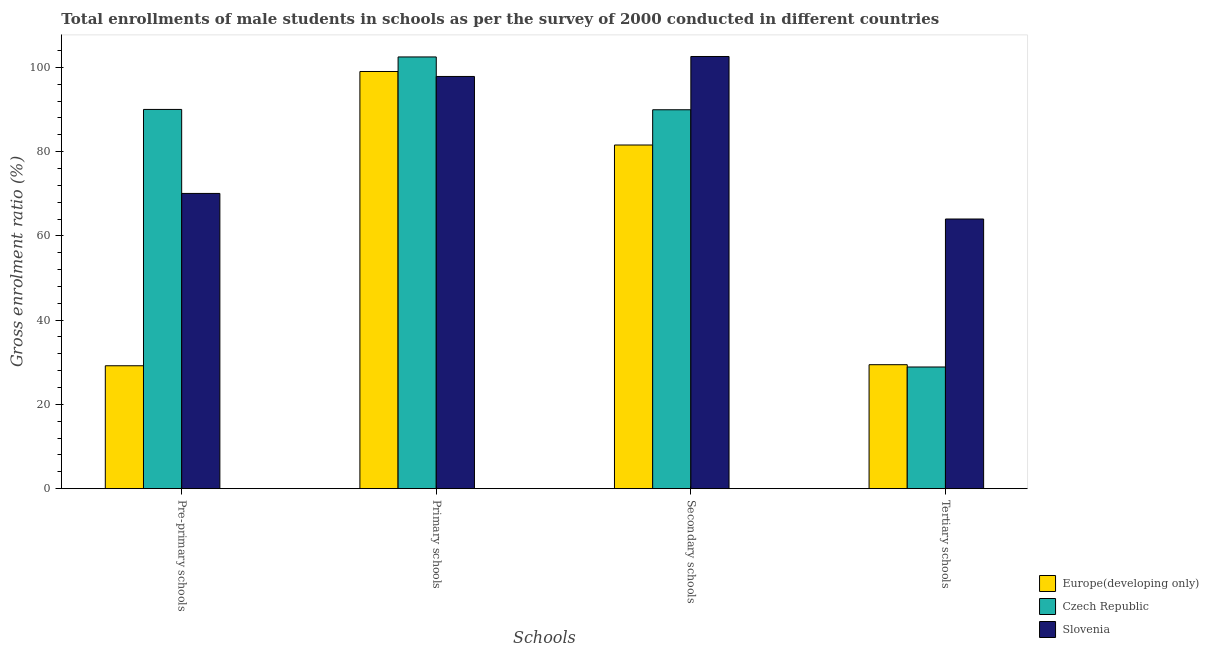How many different coloured bars are there?
Your answer should be compact. 3. How many groups of bars are there?
Your response must be concise. 4. Are the number of bars per tick equal to the number of legend labels?
Provide a short and direct response. Yes. Are the number of bars on each tick of the X-axis equal?
Give a very brief answer. Yes. What is the label of the 4th group of bars from the left?
Your answer should be compact. Tertiary schools. What is the gross enrolment ratio(male) in tertiary schools in Europe(developing only)?
Provide a short and direct response. 29.42. Across all countries, what is the maximum gross enrolment ratio(male) in pre-primary schools?
Keep it short and to the point. 90.01. Across all countries, what is the minimum gross enrolment ratio(male) in pre-primary schools?
Your answer should be compact. 29.17. In which country was the gross enrolment ratio(male) in primary schools maximum?
Your answer should be very brief. Czech Republic. In which country was the gross enrolment ratio(male) in pre-primary schools minimum?
Keep it short and to the point. Europe(developing only). What is the total gross enrolment ratio(male) in pre-primary schools in the graph?
Make the answer very short. 189.25. What is the difference between the gross enrolment ratio(male) in secondary schools in Europe(developing only) and that in Czech Republic?
Provide a succinct answer. -8.37. What is the difference between the gross enrolment ratio(male) in secondary schools in Slovenia and the gross enrolment ratio(male) in primary schools in Europe(developing only)?
Ensure brevity in your answer.  3.56. What is the average gross enrolment ratio(male) in tertiary schools per country?
Offer a terse response. 40.77. What is the difference between the gross enrolment ratio(male) in tertiary schools and gross enrolment ratio(male) in pre-primary schools in Czech Republic?
Your answer should be very brief. -61.13. What is the ratio of the gross enrolment ratio(male) in pre-primary schools in Slovenia to that in Europe(developing only)?
Keep it short and to the point. 2.4. What is the difference between the highest and the second highest gross enrolment ratio(male) in pre-primary schools?
Your response must be concise. 19.94. What is the difference between the highest and the lowest gross enrolment ratio(male) in primary schools?
Offer a terse response. 4.63. In how many countries, is the gross enrolment ratio(male) in tertiary schools greater than the average gross enrolment ratio(male) in tertiary schools taken over all countries?
Your response must be concise. 1. Is the sum of the gross enrolment ratio(male) in tertiary schools in Slovenia and Czech Republic greater than the maximum gross enrolment ratio(male) in secondary schools across all countries?
Your response must be concise. No. Is it the case that in every country, the sum of the gross enrolment ratio(male) in pre-primary schools and gross enrolment ratio(male) in primary schools is greater than the sum of gross enrolment ratio(male) in tertiary schools and gross enrolment ratio(male) in secondary schools?
Keep it short and to the point. No. What does the 3rd bar from the left in Secondary schools represents?
Your response must be concise. Slovenia. What does the 2nd bar from the right in Secondary schools represents?
Provide a succinct answer. Czech Republic. Does the graph contain grids?
Your answer should be very brief. No. How many legend labels are there?
Provide a succinct answer. 3. How are the legend labels stacked?
Make the answer very short. Vertical. What is the title of the graph?
Your response must be concise. Total enrollments of male students in schools as per the survey of 2000 conducted in different countries. Does "Small states" appear as one of the legend labels in the graph?
Your response must be concise. No. What is the label or title of the X-axis?
Offer a terse response. Schools. What is the Gross enrolment ratio (%) of Europe(developing only) in Pre-primary schools?
Ensure brevity in your answer.  29.17. What is the Gross enrolment ratio (%) of Czech Republic in Pre-primary schools?
Offer a very short reply. 90.01. What is the Gross enrolment ratio (%) in Slovenia in Pre-primary schools?
Provide a short and direct response. 70.07. What is the Gross enrolment ratio (%) in Europe(developing only) in Primary schools?
Your answer should be compact. 99.01. What is the Gross enrolment ratio (%) in Czech Republic in Primary schools?
Keep it short and to the point. 102.46. What is the Gross enrolment ratio (%) of Slovenia in Primary schools?
Your answer should be very brief. 97.83. What is the Gross enrolment ratio (%) in Europe(developing only) in Secondary schools?
Provide a succinct answer. 81.56. What is the Gross enrolment ratio (%) in Czech Republic in Secondary schools?
Offer a very short reply. 89.93. What is the Gross enrolment ratio (%) of Slovenia in Secondary schools?
Your answer should be compact. 102.57. What is the Gross enrolment ratio (%) in Europe(developing only) in Tertiary schools?
Keep it short and to the point. 29.42. What is the Gross enrolment ratio (%) of Czech Republic in Tertiary schools?
Ensure brevity in your answer.  28.88. What is the Gross enrolment ratio (%) in Slovenia in Tertiary schools?
Make the answer very short. 64. Across all Schools, what is the maximum Gross enrolment ratio (%) of Europe(developing only)?
Keep it short and to the point. 99.01. Across all Schools, what is the maximum Gross enrolment ratio (%) in Czech Republic?
Offer a very short reply. 102.46. Across all Schools, what is the maximum Gross enrolment ratio (%) in Slovenia?
Offer a terse response. 102.57. Across all Schools, what is the minimum Gross enrolment ratio (%) in Europe(developing only)?
Your answer should be very brief. 29.17. Across all Schools, what is the minimum Gross enrolment ratio (%) in Czech Republic?
Keep it short and to the point. 28.88. Across all Schools, what is the minimum Gross enrolment ratio (%) in Slovenia?
Offer a very short reply. 64. What is the total Gross enrolment ratio (%) in Europe(developing only) in the graph?
Ensure brevity in your answer.  239.17. What is the total Gross enrolment ratio (%) of Czech Republic in the graph?
Offer a very short reply. 311.27. What is the total Gross enrolment ratio (%) in Slovenia in the graph?
Give a very brief answer. 334.47. What is the difference between the Gross enrolment ratio (%) in Europe(developing only) in Pre-primary schools and that in Primary schools?
Your answer should be compact. -69.83. What is the difference between the Gross enrolment ratio (%) in Czech Republic in Pre-primary schools and that in Primary schools?
Provide a succinct answer. -12.46. What is the difference between the Gross enrolment ratio (%) of Slovenia in Pre-primary schools and that in Primary schools?
Your answer should be very brief. -27.76. What is the difference between the Gross enrolment ratio (%) of Europe(developing only) in Pre-primary schools and that in Secondary schools?
Ensure brevity in your answer.  -52.39. What is the difference between the Gross enrolment ratio (%) of Czech Republic in Pre-primary schools and that in Secondary schools?
Provide a short and direct response. 0.08. What is the difference between the Gross enrolment ratio (%) of Slovenia in Pre-primary schools and that in Secondary schools?
Give a very brief answer. -32.5. What is the difference between the Gross enrolment ratio (%) of Europe(developing only) in Pre-primary schools and that in Tertiary schools?
Your answer should be compact. -0.25. What is the difference between the Gross enrolment ratio (%) in Czech Republic in Pre-primary schools and that in Tertiary schools?
Your answer should be compact. 61.13. What is the difference between the Gross enrolment ratio (%) in Slovenia in Pre-primary schools and that in Tertiary schools?
Your response must be concise. 6.07. What is the difference between the Gross enrolment ratio (%) in Europe(developing only) in Primary schools and that in Secondary schools?
Ensure brevity in your answer.  17.45. What is the difference between the Gross enrolment ratio (%) in Czech Republic in Primary schools and that in Secondary schools?
Your answer should be very brief. 12.53. What is the difference between the Gross enrolment ratio (%) in Slovenia in Primary schools and that in Secondary schools?
Make the answer very short. -4.74. What is the difference between the Gross enrolment ratio (%) of Europe(developing only) in Primary schools and that in Tertiary schools?
Make the answer very short. 69.58. What is the difference between the Gross enrolment ratio (%) in Czech Republic in Primary schools and that in Tertiary schools?
Provide a succinct answer. 73.58. What is the difference between the Gross enrolment ratio (%) in Slovenia in Primary schools and that in Tertiary schools?
Offer a very short reply. 33.83. What is the difference between the Gross enrolment ratio (%) in Europe(developing only) in Secondary schools and that in Tertiary schools?
Offer a very short reply. 52.14. What is the difference between the Gross enrolment ratio (%) of Czech Republic in Secondary schools and that in Tertiary schools?
Provide a short and direct response. 61.05. What is the difference between the Gross enrolment ratio (%) of Slovenia in Secondary schools and that in Tertiary schools?
Make the answer very short. 38.57. What is the difference between the Gross enrolment ratio (%) in Europe(developing only) in Pre-primary schools and the Gross enrolment ratio (%) in Czech Republic in Primary schools?
Your answer should be compact. -73.29. What is the difference between the Gross enrolment ratio (%) in Europe(developing only) in Pre-primary schools and the Gross enrolment ratio (%) in Slovenia in Primary schools?
Ensure brevity in your answer.  -68.65. What is the difference between the Gross enrolment ratio (%) in Czech Republic in Pre-primary schools and the Gross enrolment ratio (%) in Slovenia in Primary schools?
Ensure brevity in your answer.  -7.82. What is the difference between the Gross enrolment ratio (%) in Europe(developing only) in Pre-primary schools and the Gross enrolment ratio (%) in Czech Republic in Secondary schools?
Offer a terse response. -60.75. What is the difference between the Gross enrolment ratio (%) in Europe(developing only) in Pre-primary schools and the Gross enrolment ratio (%) in Slovenia in Secondary schools?
Offer a terse response. -73.4. What is the difference between the Gross enrolment ratio (%) of Czech Republic in Pre-primary schools and the Gross enrolment ratio (%) of Slovenia in Secondary schools?
Provide a short and direct response. -12.56. What is the difference between the Gross enrolment ratio (%) of Europe(developing only) in Pre-primary schools and the Gross enrolment ratio (%) of Czech Republic in Tertiary schools?
Provide a short and direct response. 0.3. What is the difference between the Gross enrolment ratio (%) of Europe(developing only) in Pre-primary schools and the Gross enrolment ratio (%) of Slovenia in Tertiary schools?
Your answer should be compact. -34.83. What is the difference between the Gross enrolment ratio (%) of Czech Republic in Pre-primary schools and the Gross enrolment ratio (%) of Slovenia in Tertiary schools?
Offer a terse response. 26.01. What is the difference between the Gross enrolment ratio (%) of Europe(developing only) in Primary schools and the Gross enrolment ratio (%) of Czech Republic in Secondary schools?
Provide a succinct answer. 9.08. What is the difference between the Gross enrolment ratio (%) in Europe(developing only) in Primary schools and the Gross enrolment ratio (%) in Slovenia in Secondary schools?
Offer a very short reply. -3.56. What is the difference between the Gross enrolment ratio (%) in Czech Republic in Primary schools and the Gross enrolment ratio (%) in Slovenia in Secondary schools?
Make the answer very short. -0.11. What is the difference between the Gross enrolment ratio (%) of Europe(developing only) in Primary schools and the Gross enrolment ratio (%) of Czech Republic in Tertiary schools?
Your response must be concise. 70.13. What is the difference between the Gross enrolment ratio (%) of Europe(developing only) in Primary schools and the Gross enrolment ratio (%) of Slovenia in Tertiary schools?
Give a very brief answer. 35.01. What is the difference between the Gross enrolment ratio (%) in Czech Republic in Primary schools and the Gross enrolment ratio (%) in Slovenia in Tertiary schools?
Your response must be concise. 38.46. What is the difference between the Gross enrolment ratio (%) in Europe(developing only) in Secondary schools and the Gross enrolment ratio (%) in Czech Republic in Tertiary schools?
Provide a succinct answer. 52.68. What is the difference between the Gross enrolment ratio (%) of Europe(developing only) in Secondary schools and the Gross enrolment ratio (%) of Slovenia in Tertiary schools?
Provide a short and direct response. 17.56. What is the difference between the Gross enrolment ratio (%) of Czech Republic in Secondary schools and the Gross enrolment ratio (%) of Slovenia in Tertiary schools?
Ensure brevity in your answer.  25.93. What is the average Gross enrolment ratio (%) in Europe(developing only) per Schools?
Your answer should be very brief. 59.79. What is the average Gross enrolment ratio (%) in Czech Republic per Schools?
Your response must be concise. 77.82. What is the average Gross enrolment ratio (%) of Slovenia per Schools?
Make the answer very short. 83.62. What is the difference between the Gross enrolment ratio (%) of Europe(developing only) and Gross enrolment ratio (%) of Czech Republic in Pre-primary schools?
Give a very brief answer. -60.83. What is the difference between the Gross enrolment ratio (%) in Europe(developing only) and Gross enrolment ratio (%) in Slovenia in Pre-primary schools?
Your answer should be compact. -40.9. What is the difference between the Gross enrolment ratio (%) of Czech Republic and Gross enrolment ratio (%) of Slovenia in Pre-primary schools?
Your response must be concise. 19.94. What is the difference between the Gross enrolment ratio (%) of Europe(developing only) and Gross enrolment ratio (%) of Czech Republic in Primary schools?
Give a very brief answer. -3.45. What is the difference between the Gross enrolment ratio (%) of Europe(developing only) and Gross enrolment ratio (%) of Slovenia in Primary schools?
Your answer should be compact. 1.18. What is the difference between the Gross enrolment ratio (%) in Czech Republic and Gross enrolment ratio (%) in Slovenia in Primary schools?
Your answer should be very brief. 4.63. What is the difference between the Gross enrolment ratio (%) of Europe(developing only) and Gross enrolment ratio (%) of Czech Republic in Secondary schools?
Your answer should be very brief. -8.37. What is the difference between the Gross enrolment ratio (%) in Europe(developing only) and Gross enrolment ratio (%) in Slovenia in Secondary schools?
Provide a succinct answer. -21.01. What is the difference between the Gross enrolment ratio (%) of Czech Republic and Gross enrolment ratio (%) of Slovenia in Secondary schools?
Offer a very short reply. -12.64. What is the difference between the Gross enrolment ratio (%) of Europe(developing only) and Gross enrolment ratio (%) of Czech Republic in Tertiary schools?
Your answer should be compact. 0.55. What is the difference between the Gross enrolment ratio (%) of Europe(developing only) and Gross enrolment ratio (%) of Slovenia in Tertiary schools?
Your answer should be compact. -34.57. What is the difference between the Gross enrolment ratio (%) in Czech Republic and Gross enrolment ratio (%) in Slovenia in Tertiary schools?
Your answer should be very brief. -35.12. What is the ratio of the Gross enrolment ratio (%) in Europe(developing only) in Pre-primary schools to that in Primary schools?
Your response must be concise. 0.29. What is the ratio of the Gross enrolment ratio (%) of Czech Republic in Pre-primary schools to that in Primary schools?
Provide a succinct answer. 0.88. What is the ratio of the Gross enrolment ratio (%) of Slovenia in Pre-primary schools to that in Primary schools?
Make the answer very short. 0.72. What is the ratio of the Gross enrolment ratio (%) of Europe(developing only) in Pre-primary schools to that in Secondary schools?
Provide a short and direct response. 0.36. What is the ratio of the Gross enrolment ratio (%) in Slovenia in Pre-primary schools to that in Secondary schools?
Your response must be concise. 0.68. What is the ratio of the Gross enrolment ratio (%) of Europe(developing only) in Pre-primary schools to that in Tertiary schools?
Give a very brief answer. 0.99. What is the ratio of the Gross enrolment ratio (%) of Czech Republic in Pre-primary schools to that in Tertiary schools?
Your response must be concise. 3.12. What is the ratio of the Gross enrolment ratio (%) in Slovenia in Pre-primary schools to that in Tertiary schools?
Your response must be concise. 1.09. What is the ratio of the Gross enrolment ratio (%) of Europe(developing only) in Primary schools to that in Secondary schools?
Offer a very short reply. 1.21. What is the ratio of the Gross enrolment ratio (%) of Czech Republic in Primary schools to that in Secondary schools?
Keep it short and to the point. 1.14. What is the ratio of the Gross enrolment ratio (%) of Slovenia in Primary schools to that in Secondary schools?
Provide a short and direct response. 0.95. What is the ratio of the Gross enrolment ratio (%) in Europe(developing only) in Primary schools to that in Tertiary schools?
Give a very brief answer. 3.36. What is the ratio of the Gross enrolment ratio (%) of Czech Republic in Primary schools to that in Tertiary schools?
Give a very brief answer. 3.55. What is the ratio of the Gross enrolment ratio (%) of Slovenia in Primary schools to that in Tertiary schools?
Your response must be concise. 1.53. What is the ratio of the Gross enrolment ratio (%) in Europe(developing only) in Secondary schools to that in Tertiary schools?
Ensure brevity in your answer.  2.77. What is the ratio of the Gross enrolment ratio (%) in Czech Republic in Secondary schools to that in Tertiary schools?
Your answer should be compact. 3.11. What is the ratio of the Gross enrolment ratio (%) of Slovenia in Secondary schools to that in Tertiary schools?
Your answer should be compact. 1.6. What is the difference between the highest and the second highest Gross enrolment ratio (%) in Europe(developing only)?
Ensure brevity in your answer.  17.45. What is the difference between the highest and the second highest Gross enrolment ratio (%) of Czech Republic?
Offer a very short reply. 12.46. What is the difference between the highest and the second highest Gross enrolment ratio (%) of Slovenia?
Your answer should be very brief. 4.74. What is the difference between the highest and the lowest Gross enrolment ratio (%) of Europe(developing only)?
Offer a terse response. 69.83. What is the difference between the highest and the lowest Gross enrolment ratio (%) in Czech Republic?
Ensure brevity in your answer.  73.58. What is the difference between the highest and the lowest Gross enrolment ratio (%) in Slovenia?
Provide a succinct answer. 38.57. 